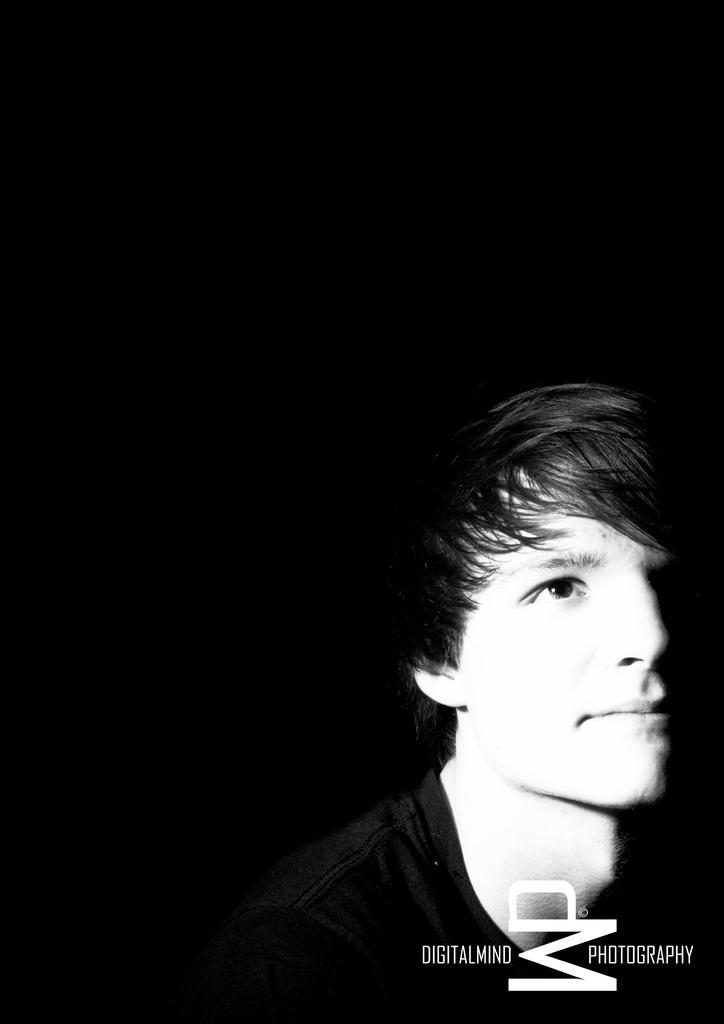Please provide a concise description of this image. This is a black and white pic and on the right side we can see a man and at the bottom there is a text written on it. 